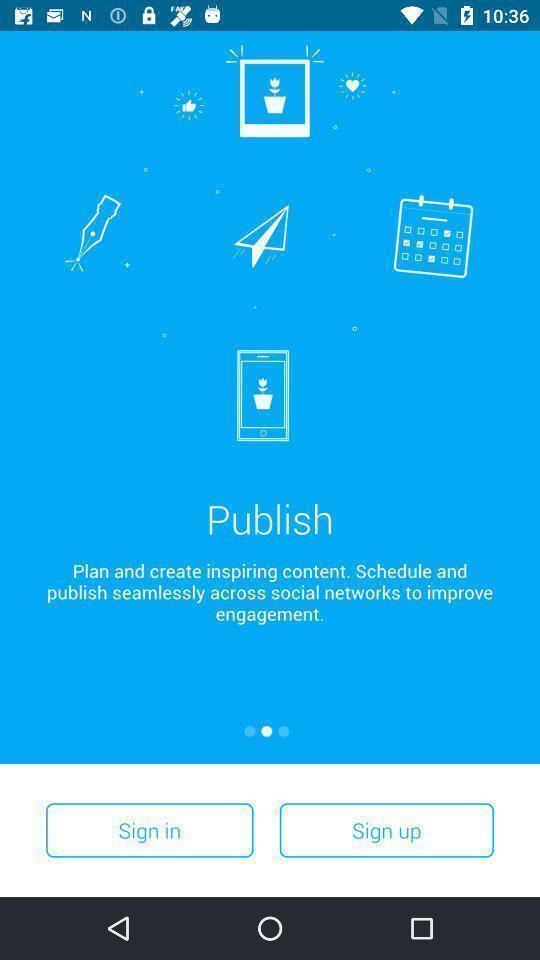What can you discern from this picture? Start page of a social app. 